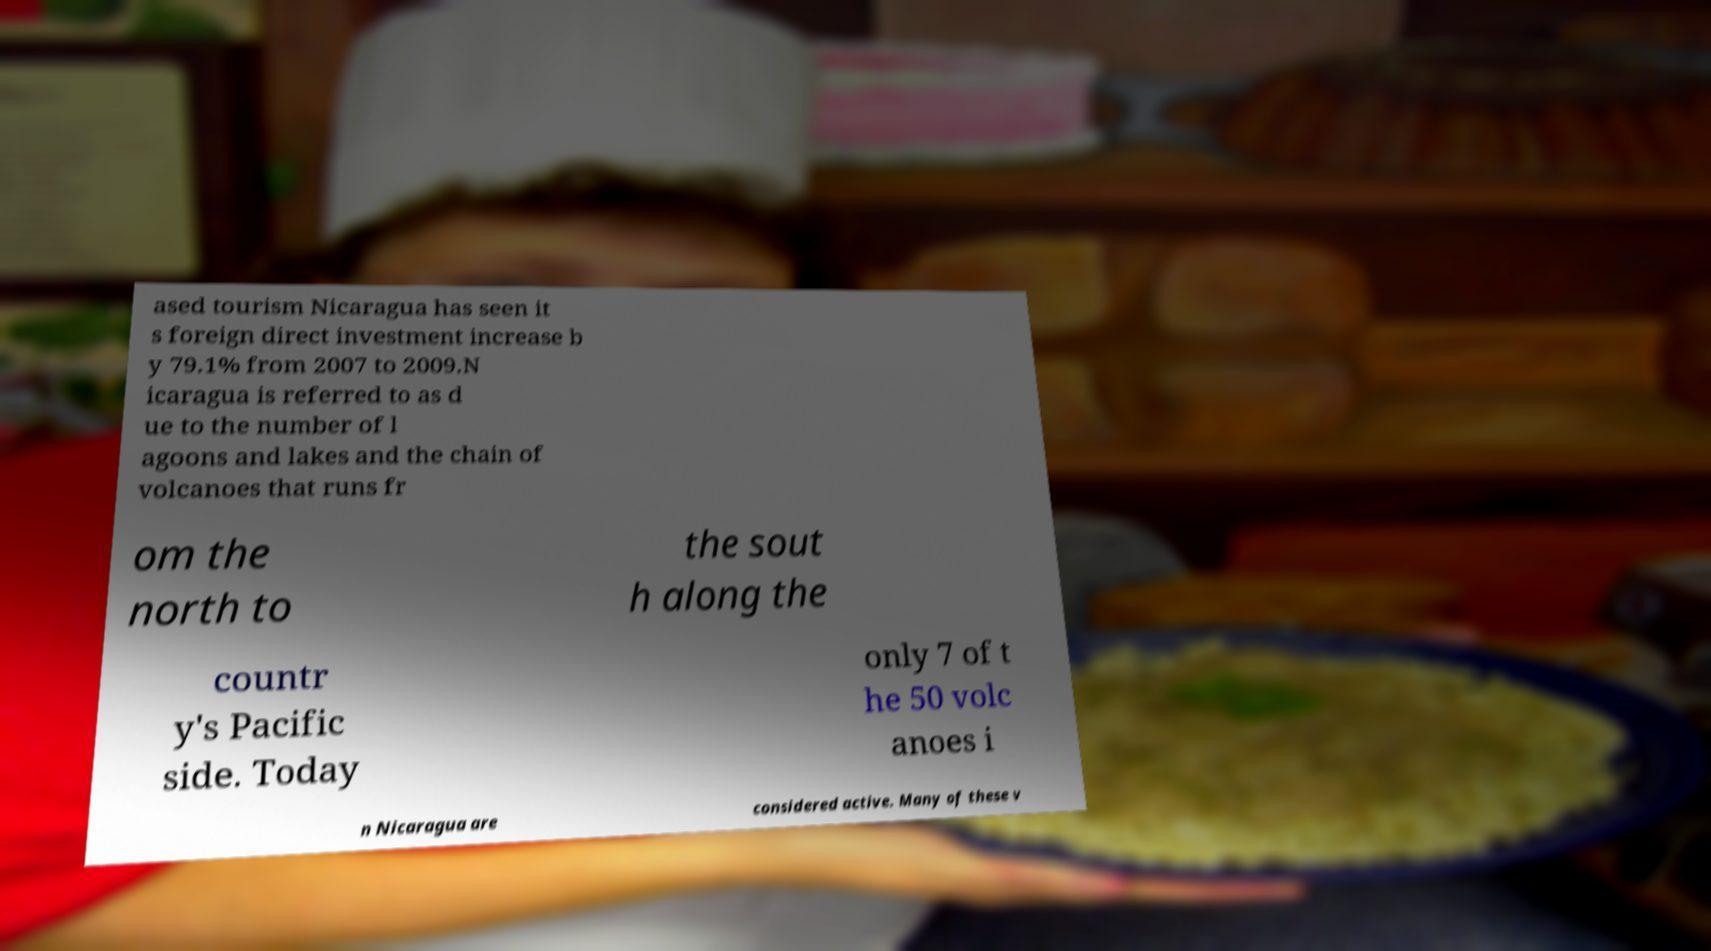Could you assist in decoding the text presented in this image and type it out clearly? ased tourism Nicaragua has seen it s foreign direct investment increase b y 79.1% from 2007 to 2009.N icaragua is referred to as d ue to the number of l agoons and lakes and the chain of volcanoes that runs fr om the north to the sout h along the countr y's Pacific side. Today only 7 of t he 50 volc anoes i n Nicaragua are considered active. Many of these v 